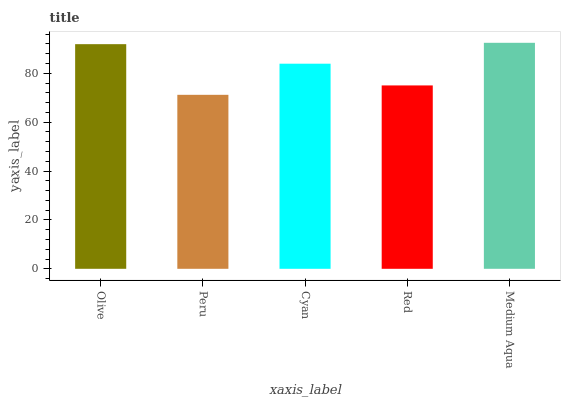Is Peru the minimum?
Answer yes or no. Yes. Is Medium Aqua the maximum?
Answer yes or no. Yes. Is Cyan the minimum?
Answer yes or no. No. Is Cyan the maximum?
Answer yes or no. No. Is Cyan greater than Peru?
Answer yes or no. Yes. Is Peru less than Cyan?
Answer yes or no. Yes. Is Peru greater than Cyan?
Answer yes or no. No. Is Cyan less than Peru?
Answer yes or no. No. Is Cyan the high median?
Answer yes or no. Yes. Is Cyan the low median?
Answer yes or no. Yes. Is Olive the high median?
Answer yes or no. No. Is Red the low median?
Answer yes or no. No. 